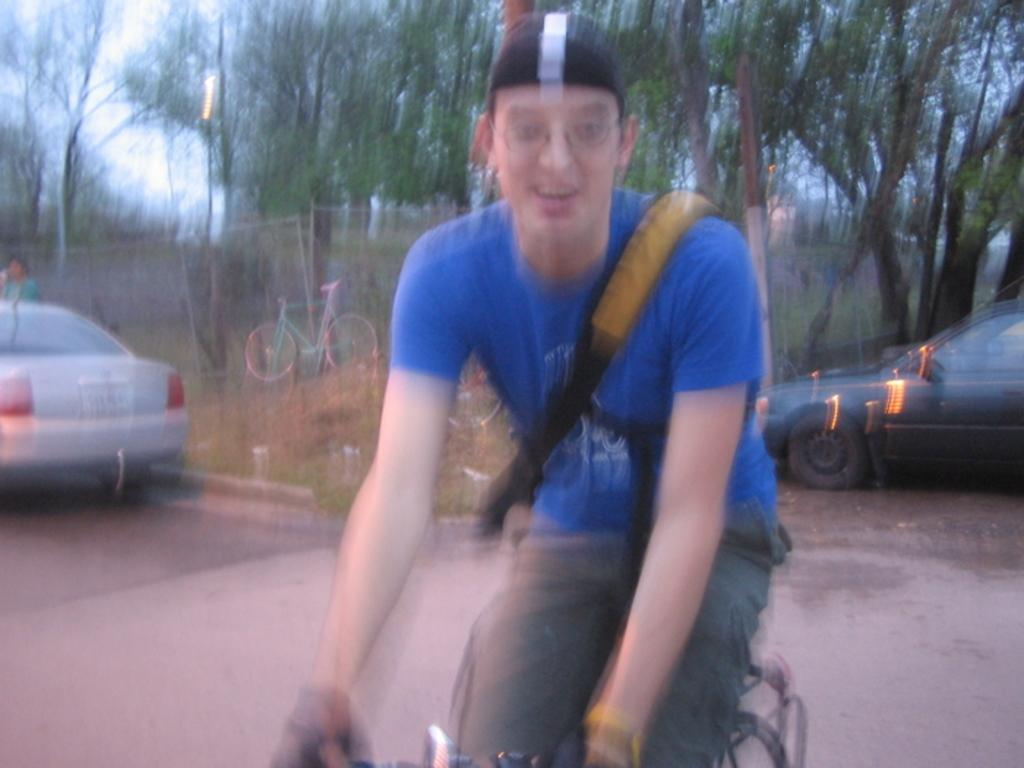Who is present in the image? There is a man in the image. What is the man doing in the image? The man is sitting on a bicycle. What can be seen in the background of the image? There are cars parked on the road in the image. How would you describe the quality of the image? The image is blurry. What is the man's purpose for swimming in the image? There is no swimming activity depicted in the image, as the man is sitting on a bicycle. 